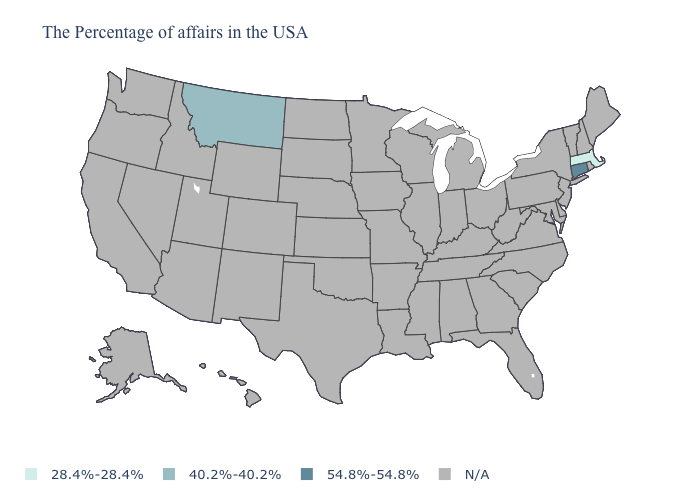Name the states that have a value in the range N/A?
Give a very brief answer. Maine, Rhode Island, New Hampshire, Vermont, New York, New Jersey, Delaware, Maryland, Pennsylvania, Virginia, North Carolina, South Carolina, West Virginia, Ohio, Florida, Georgia, Michigan, Kentucky, Indiana, Alabama, Tennessee, Wisconsin, Illinois, Mississippi, Louisiana, Missouri, Arkansas, Minnesota, Iowa, Kansas, Nebraska, Oklahoma, Texas, South Dakota, North Dakota, Wyoming, Colorado, New Mexico, Utah, Arizona, Idaho, Nevada, California, Washington, Oregon, Alaska, Hawaii. What is the highest value in the USA?
Quick response, please. 54.8%-54.8%. Does Connecticut have the highest value in the USA?
Quick response, please. Yes. Name the states that have a value in the range 28.4%-28.4%?
Answer briefly. Massachusetts. Which states have the highest value in the USA?
Concise answer only. Connecticut. Is the legend a continuous bar?
Give a very brief answer. No. Name the states that have a value in the range N/A?
Be succinct. Maine, Rhode Island, New Hampshire, Vermont, New York, New Jersey, Delaware, Maryland, Pennsylvania, Virginia, North Carolina, South Carolina, West Virginia, Ohio, Florida, Georgia, Michigan, Kentucky, Indiana, Alabama, Tennessee, Wisconsin, Illinois, Mississippi, Louisiana, Missouri, Arkansas, Minnesota, Iowa, Kansas, Nebraska, Oklahoma, Texas, South Dakota, North Dakota, Wyoming, Colorado, New Mexico, Utah, Arizona, Idaho, Nevada, California, Washington, Oregon, Alaska, Hawaii. Name the states that have a value in the range N/A?
Quick response, please. Maine, Rhode Island, New Hampshire, Vermont, New York, New Jersey, Delaware, Maryland, Pennsylvania, Virginia, North Carolina, South Carolina, West Virginia, Ohio, Florida, Georgia, Michigan, Kentucky, Indiana, Alabama, Tennessee, Wisconsin, Illinois, Mississippi, Louisiana, Missouri, Arkansas, Minnesota, Iowa, Kansas, Nebraska, Oklahoma, Texas, South Dakota, North Dakota, Wyoming, Colorado, New Mexico, Utah, Arizona, Idaho, Nevada, California, Washington, Oregon, Alaska, Hawaii. Which states have the highest value in the USA?
Short answer required. Connecticut. Name the states that have a value in the range 40.2%-40.2%?
Quick response, please. Montana. 